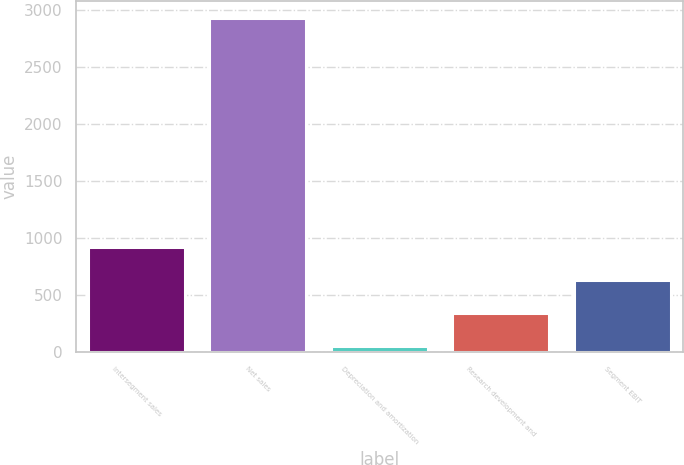Convert chart. <chart><loc_0><loc_0><loc_500><loc_500><bar_chart><fcel>Intersegment sales<fcel>Net sales<fcel>Depreciation and amortization<fcel>Research development and<fcel>Segment EBIT<nl><fcel>925<fcel>2932<fcel>59<fcel>346.3<fcel>633.6<nl></chart> 